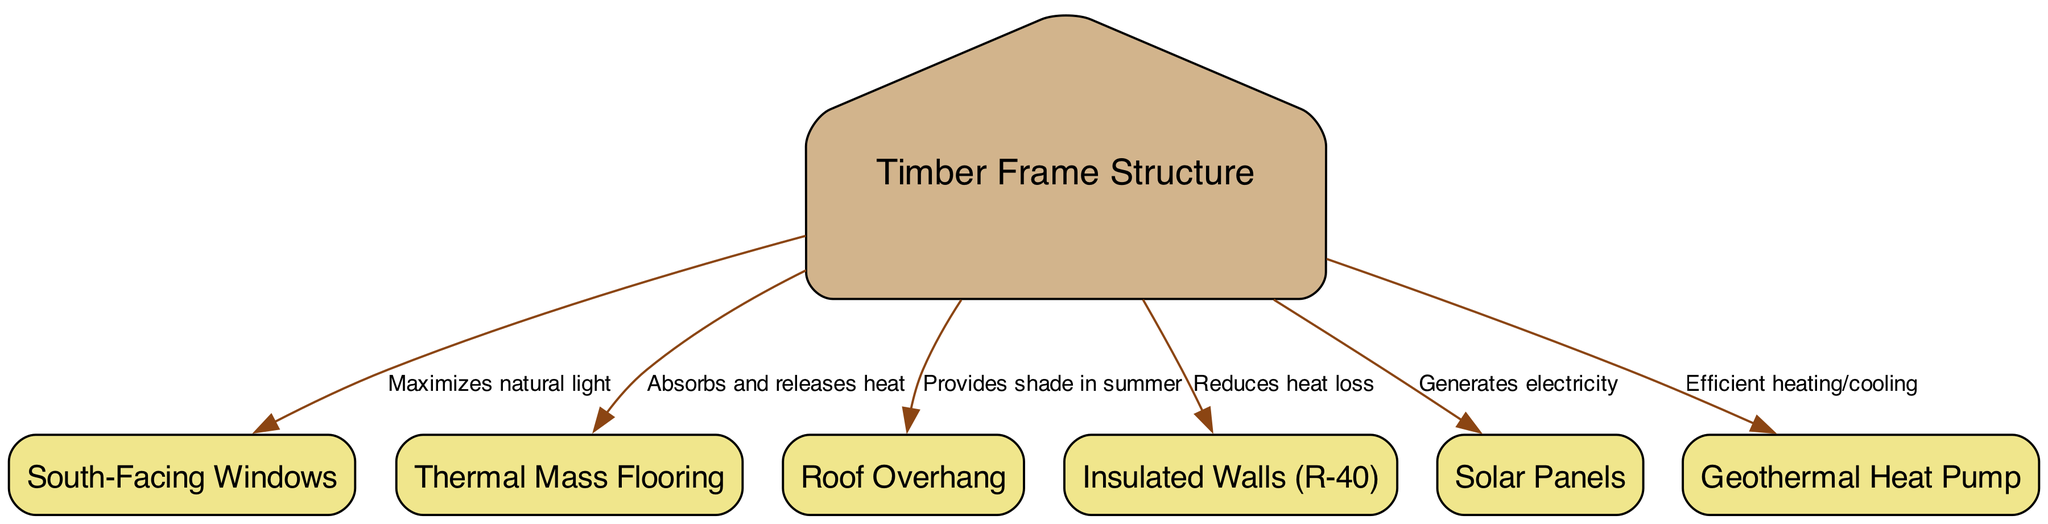What is the main structure of the home? The main structure of the home is labeled as "Timber Frame Structure" in the diagram, which indicates that the house is constructed using timber framing.
Answer: Timber Frame Structure How many elements are connected to the Timber Frame Structure? By counting the edges connected to the "Timber Frame Structure" node, there are six connections representing various features that contribute to the home's energy efficiency and design.
Answer: Six What feature maximizes natural light in the home? The "South-Facing Windows" node is specifically labeled for maximizing natural light, indicating its importance in the overall energy efficiency and ambiance of the house.
Answer: South-Facing Windows What is the purpose of the Roof Overhang? The edge connecting the "Roof Overhang" to the "Timber Frame Structure" indicates that it provides shade during the summer, which helps maintain a comfortable temperature inside the home.
Answer: Provides shade in summer How does the Thermal Mass Flooring contribute to the home? The "Thermal Mass Flooring" absorbs and releases heat, as indicated by the connection to the "Timber Frame Structure," which enhances the energy efficiency of the home by regulating indoor temperature.
Answer: Absorbs and releases heat Which component generates electricity for the home? According to the diagram, the "Solar Panels" node generates electricity, making it a vital component of the home’s energy supply and sustainability efforts.
Answer: Solar Panels What is the insulation rating of the walls? The "Insulated Walls" node is specified as (R-40), which indicates a high level of thermal resistance, contributing to energy efficiency by reducing heat loss.
Answer: R-40 How does the Geothermal Heat Pump function in the home? The edge connecting the "Geothermal Heat Pump" to the "Timber Frame Structure" highlights that it provides efficient heating and cooling, making it an essential part of the home's energy system.
Answer: Efficient heating/cooling What role do the South-Facing Windows play when combined with other elements? The combination of the "South-Facing Windows" with features like "Thermal Mass Flooring," "Insulated Walls," and other elements works collectively to enhance passive solar design and energy efficiency in the home.
Answer: Maximizes passive solar design 